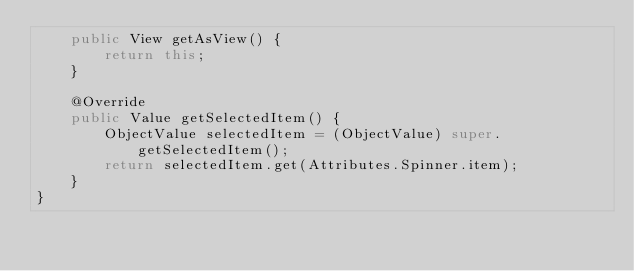<code> <loc_0><loc_0><loc_500><loc_500><_Java_>    public View getAsView() {
        return this;
    }

    @Override
    public Value getSelectedItem() {
        ObjectValue selectedItem = (ObjectValue) super.getSelectedItem();
        return selectedItem.get(Attributes.Spinner.item);
    }
}
</code> 